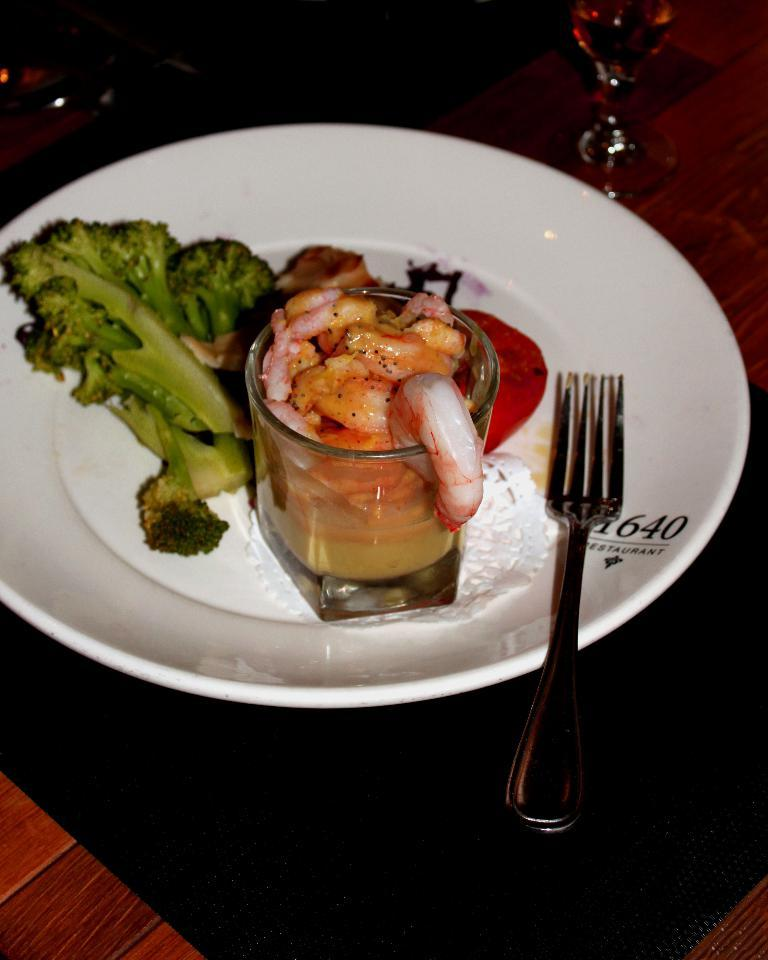What type of food item can be seen in the image? The specific food item is not mentioned, but there is a food item present in the image. What utensil is placed on the white plate? A fork is present on a white plate. What color is the cloth at the bottom of the image? The bottom of the image contains a black cloth. What type of container is at the top of the image? There is a glass at the top of the image. How many spiders are crawling on the food item in the image? There are no spiders present in the image. What type of monkey is sitting on the fork in the image? There is no monkey present in the image. 